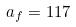Convert formula to latex. <formula><loc_0><loc_0><loc_500><loc_500>a _ { f } = 1 1 7</formula> 